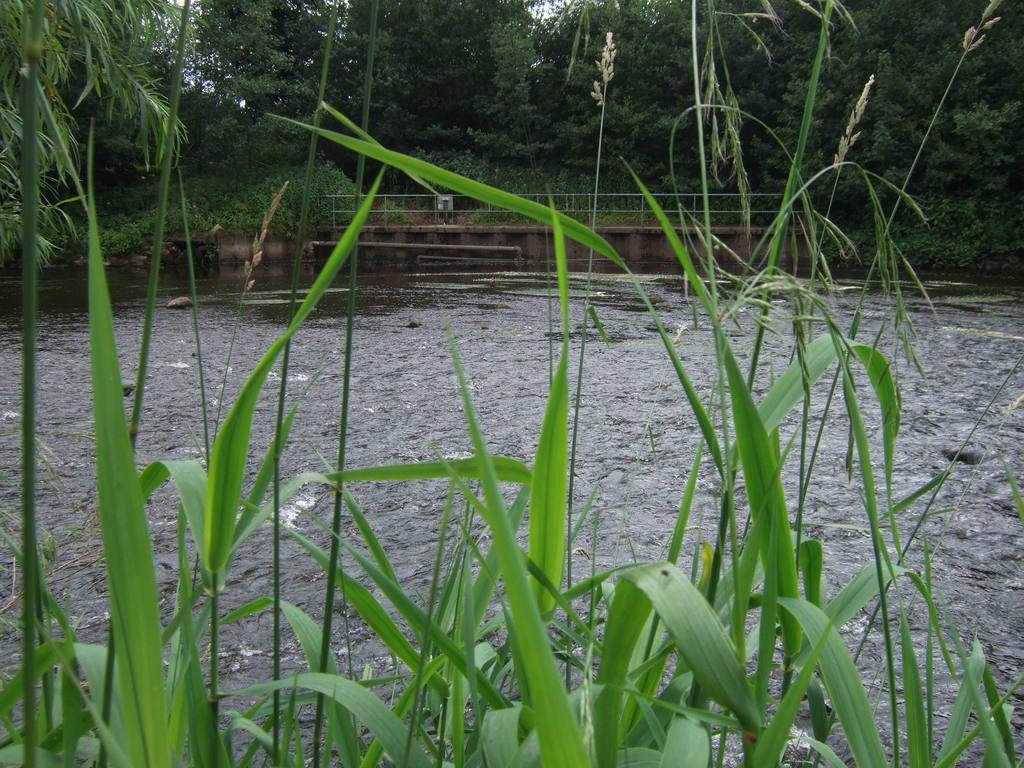What type of structure can be seen in the image? There is a bridge in the image. What type of vegetation is present in the image? There are trees and plants in the image. What natural element is visible in the image? There is water visible in the image. What type of ground cover is present in the image? There is grass in the image. How many kittens are playing with a thread in the image? There are no kittens or thread present in the image. 